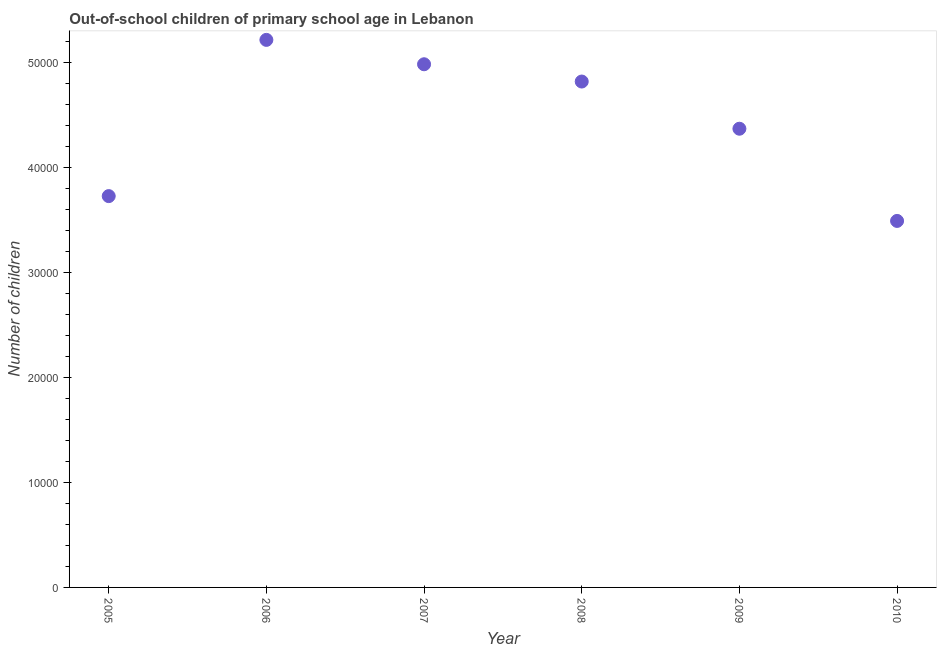What is the number of out-of-school children in 2006?
Give a very brief answer. 5.22e+04. Across all years, what is the maximum number of out-of-school children?
Give a very brief answer. 5.22e+04. Across all years, what is the minimum number of out-of-school children?
Your answer should be very brief. 3.49e+04. What is the sum of the number of out-of-school children?
Provide a short and direct response. 2.66e+05. What is the difference between the number of out-of-school children in 2009 and 2010?
Offer a terse response. 8787. What is the average number of out-of-school children per year?
Your answer should be very brief. 4.44e+04. What is the median number of out-of-school children?
Offer a very short reply. 4.60e+04. Do a majority of the years between 2006 and 2005 (inclusive) have number of out-of-school children greater than 2000 ?
Offer a terse response. No. What is the ratio of the number of out-of-school children in 2007 to that in 2010?
Your answer should be compact. 1.43. Is the number of out-of-school children in 2005 less than that in 2008?
Your response must be concise. Yes. Is the difference between the number of out-of-school children in 2007 and 2010 greater than the difference between any two years?
Your response must be concise. No. What is the difference between the highest and the second highest number of out-of-school children?
Your answer should be compact. 2324. What is the difference between the highest and the lowest number of out-of-school children?
Provide a succinct answer. 1.73e+04. In how many years, is the number of out-of-school children greater than the average number of out-of-school children taken over all years?
Your response must be concise. 3. Does the number of out-of-school children monotonically increase over the years?
Your answer should be compact. No. What is the difference between two consecutive major ticks on the Y-axis?
Provide a short and direct response. 10000. Are the values on the major ticks of Y-axis written in scientific E-notation?
Provide a succinct answer. No. What is the title of the graph?
Provide a short and direct response. Out-of-school children of primary school age in Lebanon. What is the label or title of the Y-axis?
Provide a short and direct response. Number of children. What is the Number of children in 2005?
Give a very brief answer. 3.73e+04. What is the Number of children in 2006?
Your answer should be very brief. 5.22e+04. What is the Number of children in 2007?
Ensure brevity in your answer.  4.99e+04. What is the Number of children in 2008?
Ensure brevity in your answer.  4.82e+04. What is the Number of children in 2009?
Keep it short and to the point. 4.37e+04. What is the Number of children in 2010?
Your response must be concise. 3.49e+04. What is the difference between the Number of children in 2005 and 2006?
Your response must be concise. -1.49e+04. What is the difference between the Number of children in 2005 and 2007?
Your response must be concise. -1.26e+04. What is the difference between the Number of children in 2005 and 2008?
Provide a succinct answer. -1.09e+04. What is the difference between the Number of children in 2005 and 2009?
Provide a short and direct response. -6422. What is the difference between the Number of children in 2005 and 2010?
Keep it short and to the point. 2365. What is the difference between the Number of children in 2006 and 2007?
Provide a succinct answer. 2324. What is the difference between the Number of children in 2006 and 2008?
Your response must be concise. 3970. What is the difference between the Number of children in 2006 and 2009?
Ensure brevity in your answer.  8468. What is the difference between the Number of children in 2006 and 2010?
Provide a succinct answer. 1.73e+04. What is the difference between the Number of children in 2007 and 2008?
Provide a succinct answer. 1646. What is the difference between the Number of children in 2007 and 2009?
Your answer should be very brief. 6144. What is the difference between the Number of children in 2007 and 2010?
Make the answer very short. 1.49e+04. What is the difference between the Number of children in 2008 and 2009?
Your response must be concise. 4498. What is the difference between the Number of children in 2008 and 2010?
Your response must be concise. 1.33e+04. What is the difference between the Number of children in 2009 and 2010?
Offer a terse response. 8787. What is the ratio of the Number of children in 2005 to that in 2006?
Make the answer very short. 0.71. What is the ratio of the Number of children in 2005 to that in 2007?
Make the answer very short. 0.75. What is the ratio of the Number of children in 2005 to that in 2008?
Give a very brief answer. 0.77. What is the ratio of the Number of children in 2005 to that in 2009?
Provide a short and direct response. 0.85. What is the ratio of the Number of children in 2005 to that in 2010?
Your answer should be very brief. 1.07. What is the ratio of the Number of children in 2006 to that in 2007?
Provide a succinct answer. 1.05. What is the ratio of the Number of children in 2006 to that in 2008?
Provide a short and direct response. 1.08. What is the ratio of the Number of children in 2006 to that in 2009?
Your answer should be very brief. 1.19. What is the ratio of the Number of children in 2006 to that in 2010?
Your answer should be very brief. 1.49. What is the ratio of the Number of children in 2007 to that in 2008?
Make the answer very short. 1.03. What is the ratio of the Number of children in 2007 to that in 2009?
Provide a succinct answer. 1.14. What is the ratio of the Number of children in 2007 to that in 2010?
Your answer should be compact. 1.43. What is the ratio of the Number of children in 2008 to that in 2009?
Offer a terse response. 1.1. What is the ratio of the Number of children in 2008 to that in 2010?
Give a very brief answer. 1.38. What is the ratio of the Number of children in 2009 to that in 2010?
Your answer should be compact. 1.25. 